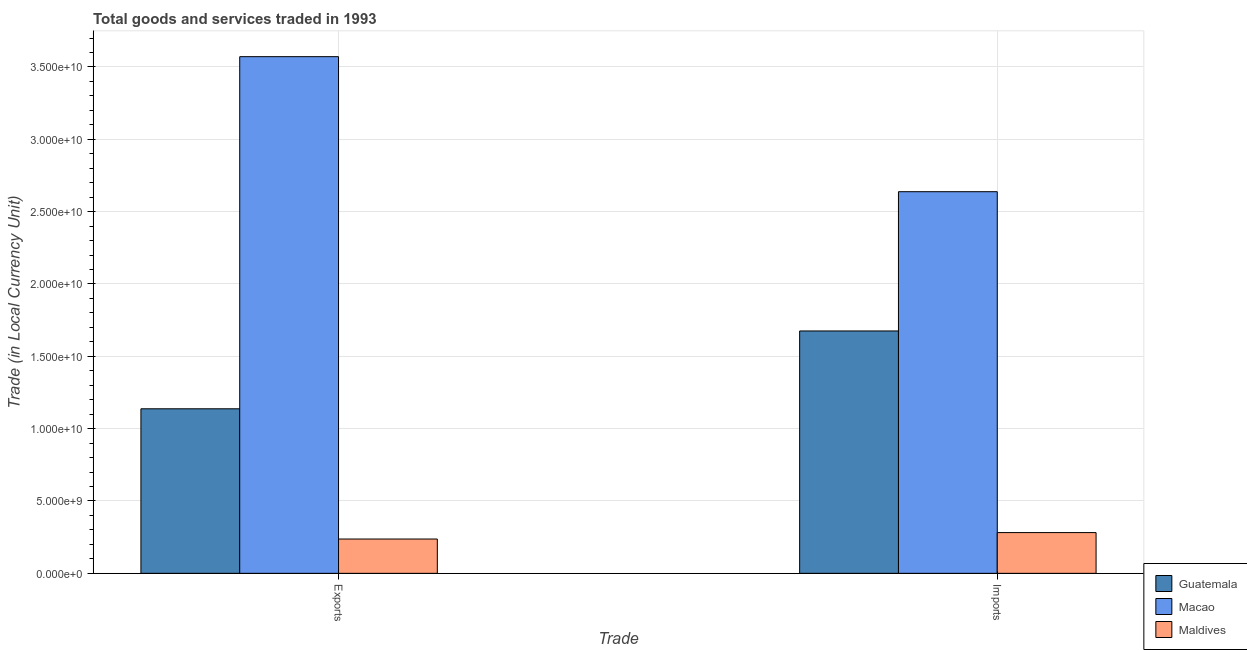How many different coloured bars are there?
Make the answer very short. 3. How many groups of bars are there?
Provide a succinct answer. 2. Are the number of bars per tick equal to the number of legend labels?
Provide a succinct answer. Yes. How many bars are there on the 1st tick from the left?
Give a very brief answer. 3. How many bars are there on the 2nd tick from the right?
Make the answer very short. 3. What is the label of the 2nd group of bars from the left?
Offer a very short reply. Imports. What is the imports of goods and services in Macao?
Give a very brief answer. 2.64e+1. Across all countries, what is the maximum imports of goods and services?
Offer a terse response. 2.64e+1. Across all countries, what is the minimum imports of goods and services?
Your answer should be compact. 2.82e+09. In which country was the export of goods and services maximum?
Ensure brevity in your answer.  Macao. In which country was the export of goods and services minimum?
Provide a succinct answer. Maldives. What is the total export of goods and services in the graph?
Your answer should be compact. 4.95e+1. What is the difference between the imports of goods and services in Maldives and that in Guatemala?
Your answer should be compact. -1.39e+1. What is the difference between the export of goods and services in Maldives and the imports of goods and services in Guatemala?
Offer a terse response. -1.44e+1. What is the average imports of goods and services per country?
Keep it short and to the point. 1.53e+1. What is the difference between the imports of goods and services and export of goods and services in Maldives?
Offer a terse response. 4.45e+08. In how many countries, is the imports of goods and services greater than 30000000000 LCU?
Your answer should be compact. 0. What is the ratio of the imports of goods and services in Macao to that in Maldives?
Your response must be concise. 9.37. Is the imports of goods and services in Guatemala less than that in Maldives?
Offer a terse response. No. In how many countries, is the export of goods and services greater than the average export of goods and services taken over all countries?
Ensure brevity in your answer.  1. What does the 2nd bar from the left in Imports represents?
Ensure brevity in your answer.  Macao. What does the 2nd bar from the right in Exports represents?
Give a very brief answer. Macao. Are all the bars in the graph horizontal?
Keep it short and to the point. No. How many countries are there in the graph?
Keep it short and to the point. 3. What is the difference between two consecutive major ticks on the Y-axis?
Make the answer very short. 5.00e+09. Are the values on the major ticks of Y-axis written in scientific E-notation?
Offer a terse response. Yes. Where does the legend appear in the graph?
Offer a terse response. Bottom right. How many legend labels are there?
Provide a succinct answer. 3. How are the legend labels stacked?
Provide a short and direct response. Vertical. What is the title of the graph?
Make the answer very short. Total goods and services traded in 1993. What is the label or title of the X-axis?
Keep it short and to the point. Trade. What is the label or title of the Y-axis?
Your response must be concise. Trade (in Local Currency Unit). What is the Trade (in Local Currency Unit) in Guatemala in Exports?
Make the answer very short. 1.14e+1. What is the Trade (in Local Currency Unit) in Macao in Exports?
Offer a terse response. 3.57e+1. What is the Trade (in Local Currency Unit) of Maldives in Exports?
Make the answer very short. 2.37e+09. What is the Trade (in Local Currency Unit) in Guatemala in Imports?
Keep it short and to the point. 1.68e+1. What is the Trade (in Local Currency Unit) in Macao in Imports?
Keep it short and to the point. 2.64e+1. What is the Trade (in Local Currency Unit) of Maldives in Imports?
Offer a very short reply. 2.82e+09. Across all Trade, what is the maximum Trade (in Local Currency Unit) in Guatemala?
Your response must be concise. 1.68e+1. Across all Trade, what is the maximum Trade (in Local Currency Unit) of Macao?
Give a very brief answer. 3.57e+1. Across all Trade, what is the maximum Trade (in Local Currency Unit) of Maldives?
Give a very brief answer. 2.82e+09. Across all Trade, what is the minimum Trade (in Local Currency Unit) of Guatemala?
Your answer should be very brief. 1.14e+1. Across all Trade, what is the minimum Trade (in Local Currency Unit) of Macao?
Your answer should be compact. 2.64e+1. Across all Trade, what is the minimum Trade (in Local Currency Unit) of Maldives?
Your response must be concise. 2.37e+09. What is the total Trade (in Local Currency Unit) in Guatemala in the graph?
Make the answer very short. 2.81e+1. What is the total Trade (in Local Currency Unit) of Macao in the graph?
Provide a short and direct response. 6.21e+1. What is the total Trade (in Local Currency Unit) of Maldives in the graph?
Offer a very short reply. 5.19e+09. What is the difference between the Trade (in Local Currency Unit) in Guatemala in Exports and that in Imports?
Offer a terse response. -5.38e+09. What is the difference between the Trade (in Local Currency Unit) of Macao in Exports and that in Imports?
Offer a terse response. 9.33e+09. What is the difference between the Trade (in Local Currency Unit) of Maldives in Exports and that in Imports?
Your response must be concise. -4.45e+08. What is the difference between the Trade (in Local Currency Unit) of Guatemala in Exports and the Trade (in Local Currency Unit) of Macao in Imports?
Provide a short and direct response. -1.50e+1. What is the difference between the Trade (in Local Currency Unit) in Guatemala in Exports and the Trade (in Local Currency Unit) in Maldives in Imports?
Your answer should be very brief. 8.56e+09. What is the difference between the Trade (in Local Currency Unit) in Macao in Exports and the Trade (in Local Currency Unit) in Maldives in Imports?
Keep it short and to the point. 3.29e+1. What is the average Trade (in Local Currency Unit) of Guatemala per Trade?
Keep it short and to the point. 1.41e+1. What is the average Trade (in Local Currency Unit) in Macao per Trade?
Provide a short and direct response. 3.10e+1. What is the average Trade (in Local Currency Unit) in Maldives per Trade?
Provide a succinct answer. 2.59e+09. What is the difference between the Trade (in Local Currency Unit) in Guatemala and Trade (in Local Currency Unit) in Macao in Exports?
Provide a short and direct response. -2.43e+1. What is the difference between the Trade (in Local Currency Unit) in Guatemala and Trade (in Local Currency Unit) in Maldives in Exports?
Your answer should be very brief. 9.00e+09. What is the difference between the Trade (in Local Currency Unit) of Macao and Trade (in Local Currency Unit) of Maldives in Exports?
Ensure brevity in your answer.  3.33e+1. What is the difference between the Trade (in Local Currency Unit) in Guatemala and Trade (in Local Currency Unit) in Macao in Imports?
Provide a succinct answer. -9.63e+09. What is the difference between the Trade (in Local Currency Unit) in Guatemala and Trade (in Local Currency Unit) in Maldives in Imports?
Keep it short and to the point. 1.39e+1. What is the difference between the Trade (in Local Currency Unit) in Macao and Trade (in Local Currency Unit) in Maldives in Imports?
Make the answer very short. 2.36e+1. What is the ratio of the Trade (in Local Currency Unit) in Guatemala in Exports to that in Imports?
Make the answer very short. 0.68. What is the ratio of the Trade (in Local Currency Unit) of Macao in Exports to that in Imports?
Provide a succinct answer. 1.35. What is the ratio of the Trade (in Local Currency Unit) of Maldives in Exports to that in Imports?
Ensure brevity in your answer.  0.84. What is the difference between the highest and the second highest Trade (in Local Currency Unit) of Guatemala?
Your answer should be very brief. 5.38e+09. What is the difference between the highest and the second highest Trade (in Local Currency Unit) of Macao?
Offer a terse response. 9.33e+09. What is the difference between the highest and the second highest Trade (in Local Currency Unit) in Maldives?
Provide a succinct answer. 4.45e+08. What is the difference between the highest and the lowest Trade (in Local Currency Unit) of Guatemala?
Make the answer very short. 5.38e+09. What is the difference between the highest and the lowest Trade (in Local Currency Unit) of Macao?
Keep it short and to the point. 9.33e+09. What is the difference between the highest and the lowest Trade (in Local Currency Unit) in Maldives?
Your answer should be compact. 4.45e+08. 